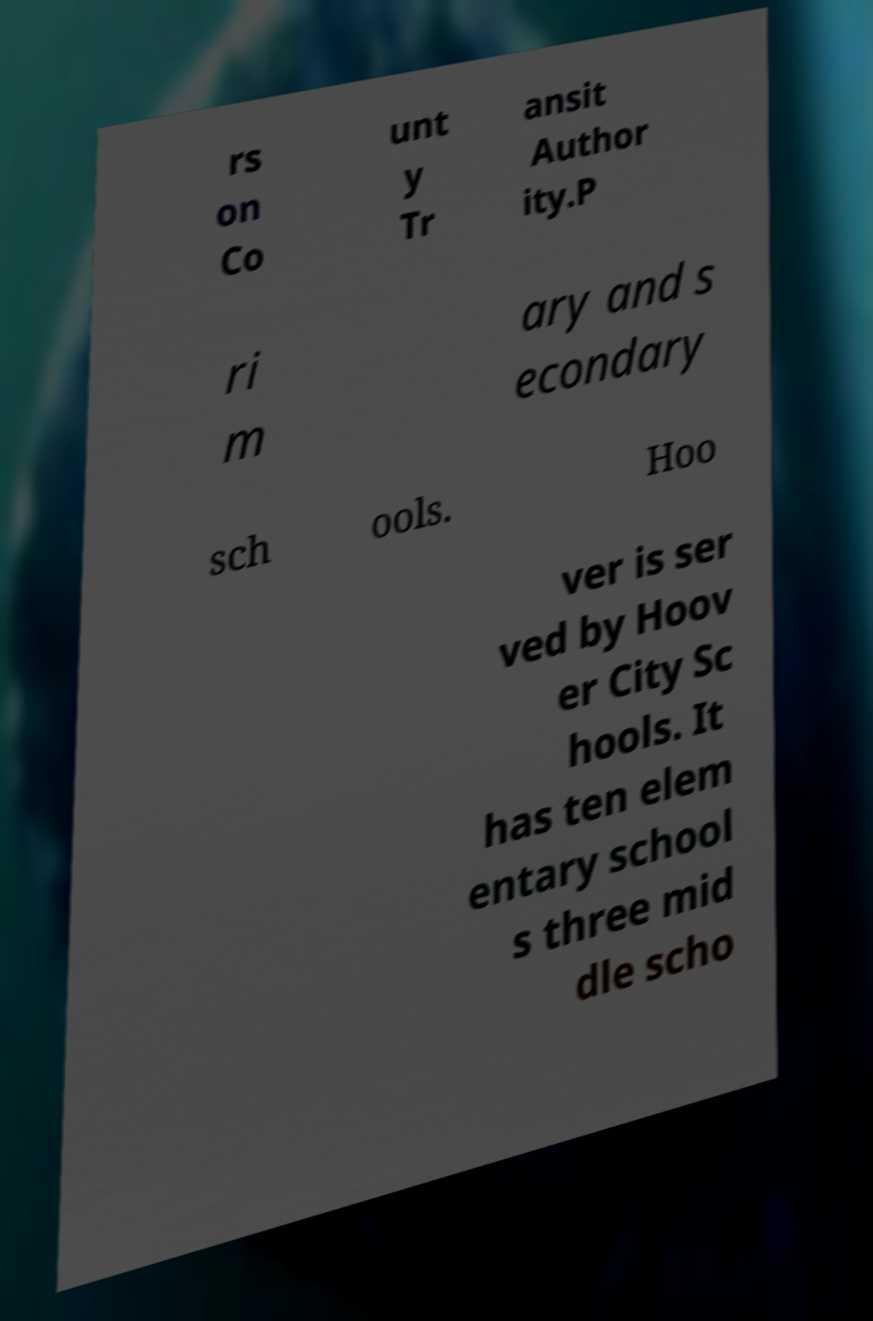What messages or text are displayed in this image? I need them in a readable, typed format. rs on Co unt y Tr ansit Author ity.P ri m ary and s econdary sch ools. Hoo ver is ser ved by Hoov er City Sc hools. It has ten elem entary school s three mid dle scho 